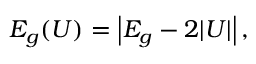<formula> <loc_0><loc_0><loc_500><loc_500>E _ { g } ( U ) = \left | E _ { g } - 2 | U | \right | ,</formula> 